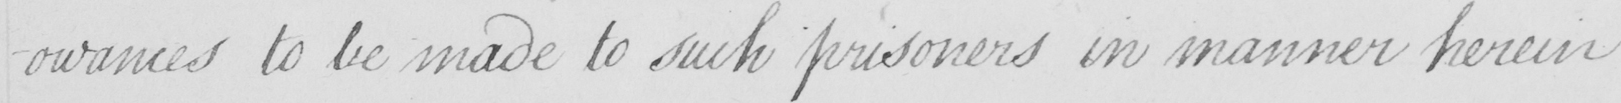What does this handwritten line say? -owances to be made to such prisoners in manner herein 